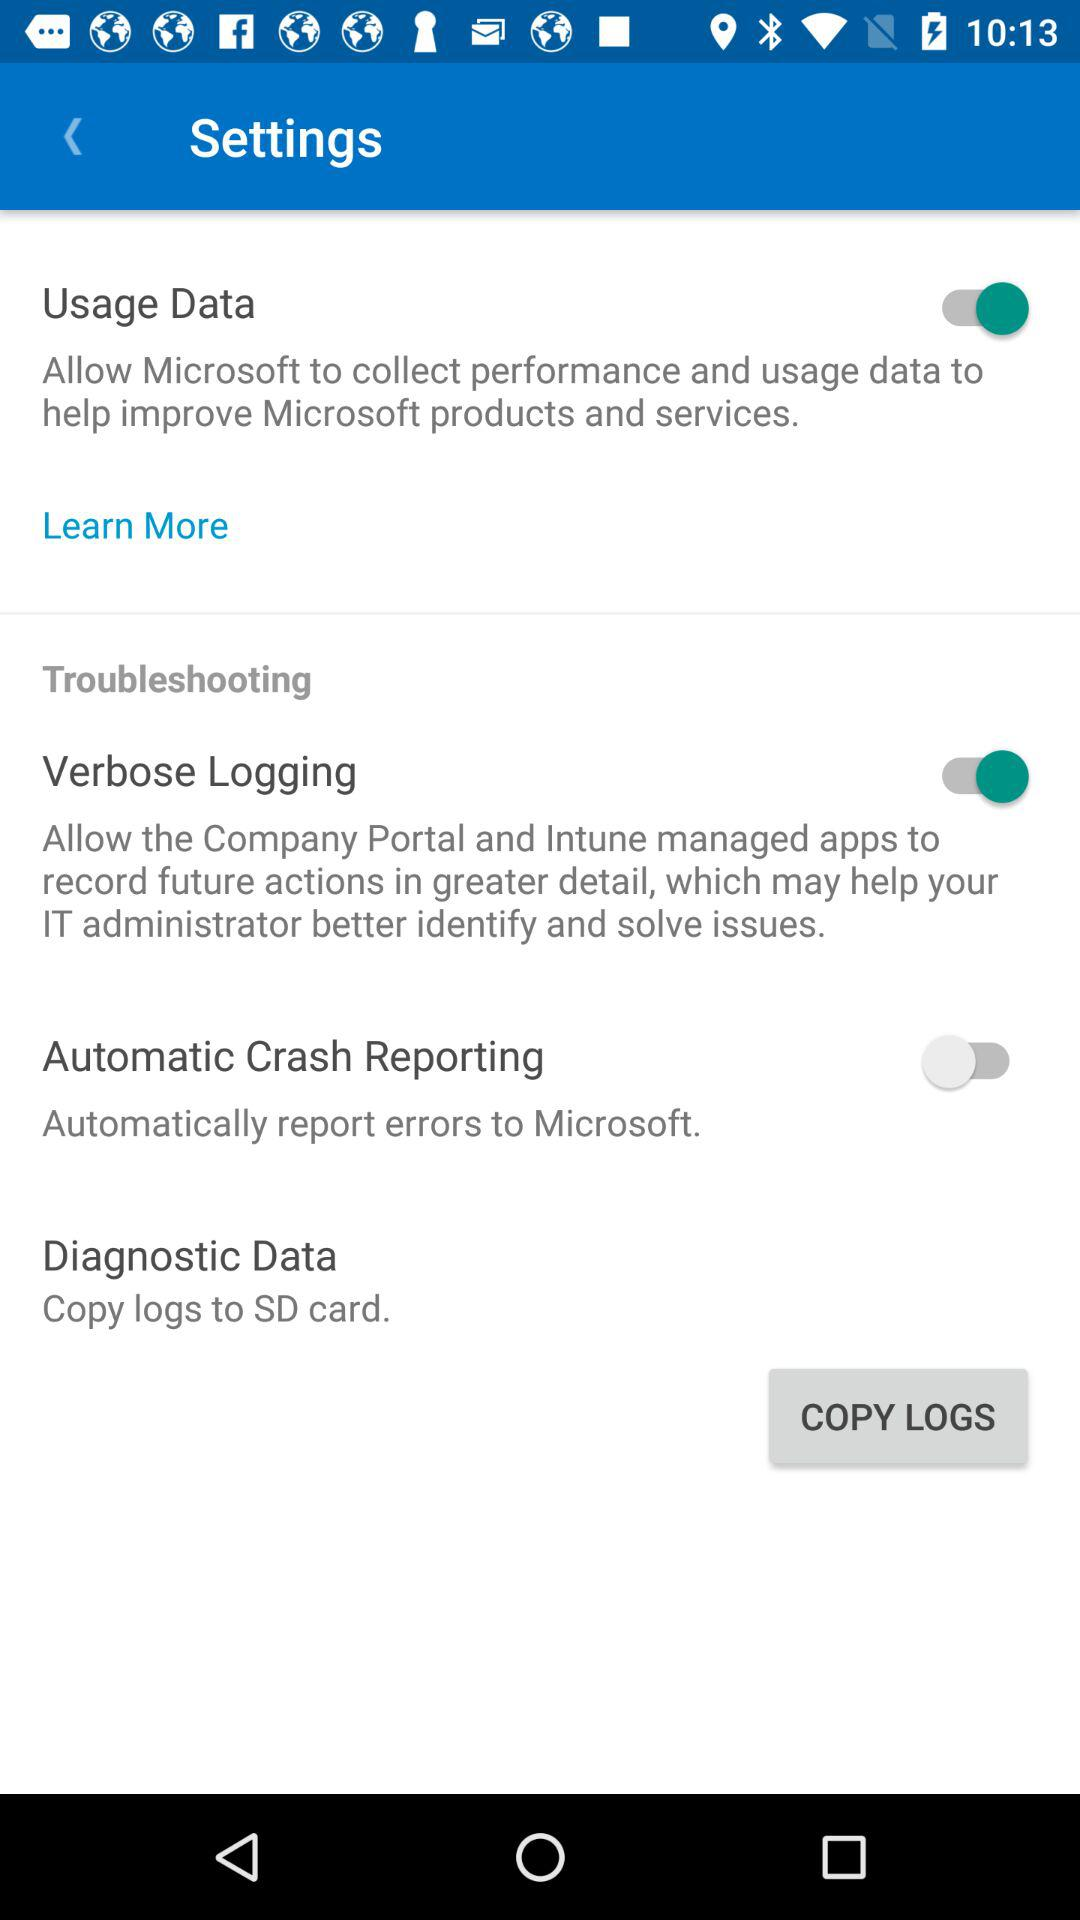What is the status of "Usage Data"? The status is "on". 